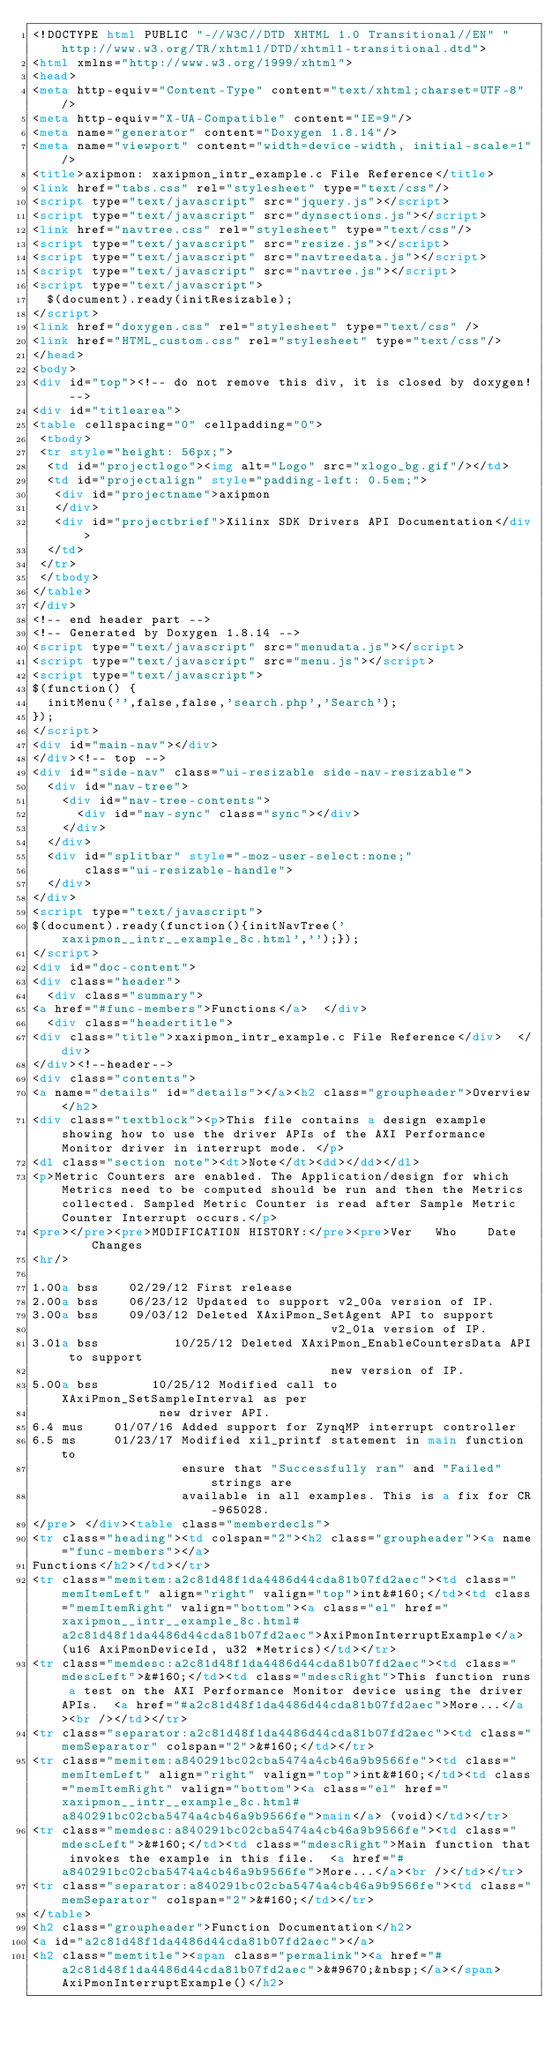Convert code to text. <code><loc_0><loc_0><loc_500><loc_500><_HTML_><!DOCTYPE html PUBLIC "-//W3C//DTD XHTML 1.0 Transitional//EN" "http://www.w3.org/TR/xhtml1/DTD/xhtml1-transitional.dtd">
<html xmlns="http://www.w3.org/1999/xhtml">
<head>
<meta http-equiv="Content-Type" content="text/xhtml;charset=UTF-8"/>
<meta http-equiv="X-UA-Compatible" content="IE=9"/>
<meta name="generator" content="Doxygen 1.8.14"/>
<meta name="viewport" content="width=device-width, initial-scale=1"/>
<title>axipmon: xaxipmon_intr_example.c File Reference</title>
<link href="tabs.css" rel="stylesheet" type="text/css"/>
<script type="text/javascript" src="jquery.js"></script>
<script type="text/javascript" src="dynsections.js"></script>
<link href="navtree.css" rel="stylesheet" type="text/css"/>
<script type="text/javascript" src="resize.js"></script>
<script type="text/javascript" src="navtreedata.js"></script>
<script type="text/javascript" src="navtree.js"></script>
<script type="text/javascript">
  $(document).ready(initResizable);
</script>
<link href="doxygen.css" rel="stylesheet" type="text/css" />
<link href="HTML_custom.css" rel="stylesheet" type="text/css"/>
</head>
<body>
<div id="top"><!-- do not remove this div, it is closed by doxygen! -->
<div id="titlearea">
<table cellspacing="0" cellpadding="0">
 <tbody>
 <tr style="height: 56px;">
  <td id="projectlogo"><img alt="Logo" src="xlogo_bg.gif"/></td>
  <td id="projectalign" style="padding-left: 0.5em;">
   <div id="projectname">axipmon
   </div>
   <div id="projectbrief">Xilinx SDK Drivers API Documentation</div>
  </td>
 </tr>
 </tbody>
</table>
</div>
<!-- end header part -->
<!-- Generated by Doxygen 1.8.14 -->
<script type="text/javascript" src="menudata.js"></script>
<script type="text/javascript" src="menu.js"></script>
<script type="text/javascript">
$(function() {
  initMenu('',false,false,'search.php','Search');
});
</script>
<div id="main-nav"></div>
</div><!-- top -->
<div id="side-nav" class="ui-resizable side-nav-resizable">
  <div id="nav-tree">
    <div id="nav-tree-contents">
      <div id="nav-sync" class="sync"></div>
    </div>
  </div>
  <div id="splitbar" style="-moz-user-select:none;" 
       class="ui-resizable-handle">
  </div>
</div>
<script type="text/javascript">
$(document).ready(function(){initNavTree('xaxipmon__intr__example_8c.html','');});
</script>
<div id="doc-content">
<div class="header">
  <div class="summary">
<a href="#func-members">Functions</a>  </div>
  <div class="headertitle">
<div class="title">xaxipmon_intr_example.c File Reference</div>  </div>
</div><!--header-->
<div class="contents">
<a name="details" id="details"></a><h2 class="groupheader">Overview</h2>
<div class="textblock"><p>This file contains a design example showing how to use the driver APIs of the AXI Performance Monitor driver in interrupt mode. </p>
<dl class="section note"><dt>Note</dt><dd></dd></dl>
<p>Metric Counters are enabled. The Application/design for which Metrics need to be computed should be run and then the Metrics collected. Sampled Metric Counter is read after Sample Metric Counter Interrupt occurs.</p>
<pre></pre><pre>MODIFICATION HISTORY:</pre><pre>Ver   Who    Date     Changes
<hr/>

1.00a bss    02/29/12 First release
2.00a bss    06/23/12 Updated to support v2_00a version of IP.
3.00a bss    09/03/12 Deleted XAxiPmon_SetAgent API to support
                                        v2_01a version of IP.
3.01a bss          10/25/12 Deleted XAxiPmon_EnableCountersData API to support
                                        new version of IP.
5.00a bss       10/25/12 Modified call to XAxiPmon_SetSampleInterval as per
                 new driver API.
6.4 mus    01/07/16 Added support for ZynqMP interrupt controller
6.5 ms     01/23/17 Modified xil_printf statement in main function to
                    ensure that "Successfully ran" and "Failed" strings are
                    available in all examples. This is a fix for CR-965028.
</pre> </div><table class="memberdecls">
<tr class="heading"><td colspan="2"><h2 class="groupheader"><a name="func-members"></a>
Functions</h2></td></tr>
<tr class="memitem:a2c81d48f1da4486d44cda81b07fd2aec"><td class="memItemLeft" align="right" valign="top">int&#160;</td><td class="memItemRight" valign="bottom"><a class="el" href="xaxipmon__intr__example_8c.html#a2c81d48f1da4486d44cda81b07fd2aec">AxiPmonInterruptExample</a> (u16 AxiPmonDeviceId, u32 *Metrics)</td></tr>
<tr class="memdesc:a2c81d48f1da4486d44cda81b07fd2aec"><td class="mdescLeft">&#160;</td><td class="mdescRight">This function runs a test on the AXI Performance Monitor device using the driver APIs.  <a href="#a2c81d48f1da4486d44cda81b07fd2aec">More...</a><br /></td></tr>
<tr class="separator:a2c81d48f1da4486d44cda81b07fd2aec"><td class="memSeparator" colspan="2">&#160;</td></tr>
<tr class="memitem:a840291bc02cba5474a4cb46a9b9566fe"><td class="memItemLeft" align="right" valign="top">int&#160;</td><td class="memItemRight" valign="bottom"><a class="el" href="xaxipmon__intr__example_8c.html#a840291bc02cba5474a4cb46a9b9566fe">main</a> (void)</td></tr>
<tr class="memdesc:a840291bc02cba5474a4cb46a9b9566fe"><td class="mdescLeft">&#160;</td><td class="mdescRight">Main function that invokes the example in this file.  <a href="#a840291bc02cba5474a4cb46a9b9566fe">More...</a><br /></td></tr>
<tr class="separator:a840291bc02cba5474a4cb46a9b9566fe"><td class="memSeparator" colspan="2">&#160;</td></tr>
</table>
<h2 class="groupheader">Function Documentation</h2>
<a id="a2c81d48f1da4486d44cda81b07fd2aec"></a>
<h2 class="memtitle"><span class="permalink"><a href="#a2c81d48f1da4486d44cda81b07fd2aec">&#9670;&nbsp;</a></span>AxiPmonInterruptExample()</h2>
</code> 